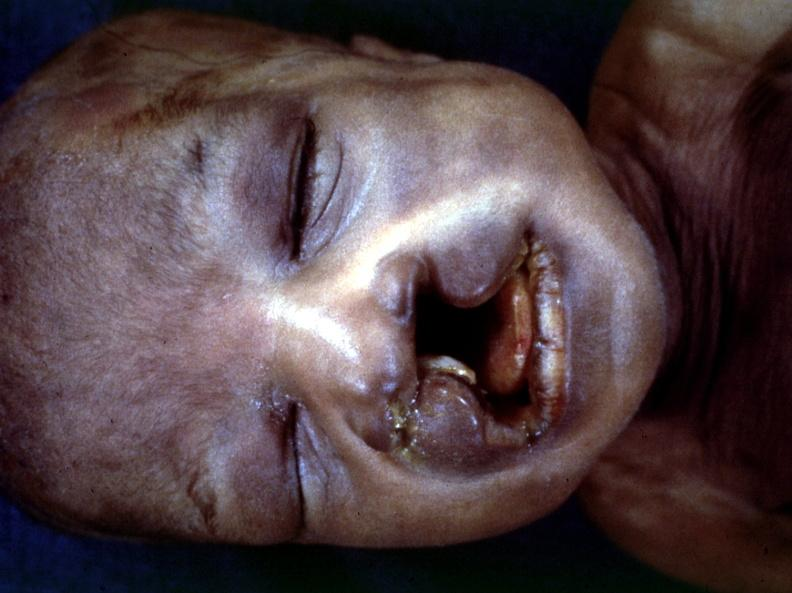s natural color present?
Answer the question using a single word or phrase. No 